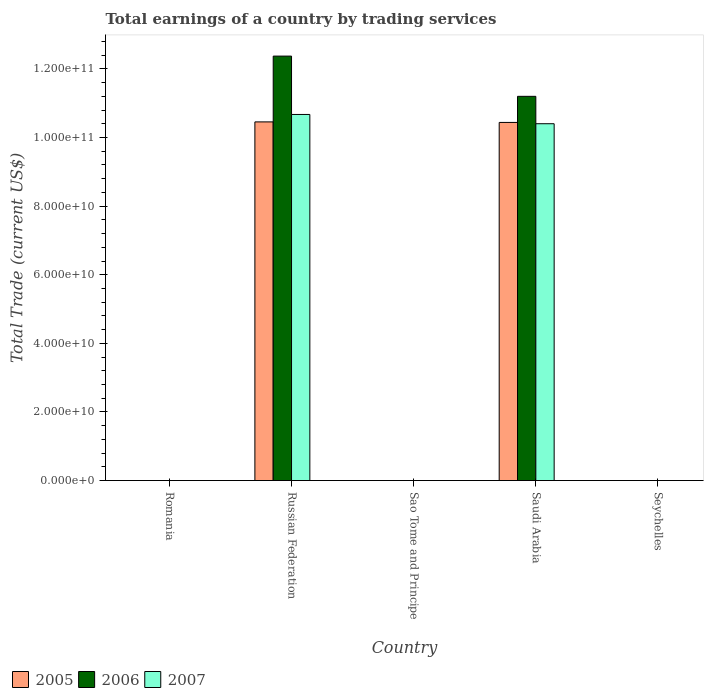How many different coloured bars are there?
Your response must be concise. 3. Are the number of bars on each tick of the X-axis equal?
Your answer should be compact. No. How many bars are there on the 3rd tick from the right?
Your response must be concise. 0. What is the label of the 4th group of bars from the left?
Provide a succinct answer. Saudi Arabia. What is the total earnings in 2005 in Russian Federation?
Your answer should be compact. 1.05e+11. Across all countries, what is the maximum total earnings in 2005?
Keep it short and to the point. 1.05e+11. Across all countries, what is the minimum total earnings in 2005?
Give a very brief answer. 0. In which country was the total earnings in 2007 maximum?
Your answer should be compact. Russian Federation. What is the total total earnings in 2006 in the graph?
Keep it short and to the point. 2.36e+11. What is the difference between the total earnings in 2007 in Russian Federation and that in Saudi Arabia?
Provide a succinct answer. 2.70e+09. What is the average total earnings in 2006 per country?
Give a very brief answer. 4.72e+1. What is the difference between the total earnings of/in 2006 and total earnings of/in 2007 in Russian Federation?
Offer a terse response. 1.70e+1. In how many countries, is the total earnings in 2006 greater than 12000000000 US$?
Provide a succinct answer. 2. What is the ratio of the total earnings in 2005 in Russian Federation to that in Saudi Arabia?
Offer a terse response. 1. What is the difference between the highest and the lowest total earnings in 2006?
Ensure brevity in your answer.  1.24e+11. In how many countries, is the total earnings in 2007 greater than the average total earnings in 2007 taken over all countries?
Make the answer very short. 2. How many countries are there in the graph?
Your answer should be compact. 5. What is the difference between two consecutive major ticks on the Y-axis?
Offer a very short reply. 2.00e+1. Does the graph contain any zero values?
Provide a short and direct response. Yes. How many legend labels are there?
Keep it short and to the point. 3. How are the legend labels stacked?
Your answer should be very brief. Horizontal. What is the title of the graph?
Your answer should be compact. Total earnings of a country by trading services. Does "1976" appear as one of the legend labels in the graph?
Keep it short and to the point. No. What is the label or title of the Y-axis?
Provide a short and direct response. Total Trade (current US$). What is the Total Trade (current US$) of 2006 in Romania?
Your response must be concise. 0. What is the Total Trade (current US$) in 2005 in Russian Federation?
Give a very brief answer. 1.05e+11. What is the Total Trade (current US$) in 2006 in Russian Federation?
Make the answer very short. 1.24e+11. What is the Total Trade (current US$) of 2007 in Russian Federation?
Keep it short and to the point. 1.07e+11. What is the Total Trade (current US$) of 2005 in Sao Tome and Principe?
Make the answer very short. 0. What is the Total Trade (current US$) in 2005 in Saudi Arabia?
Ensure brevity in your answer.  1.04e+11. What is the Total Trade (current US$) of 2006 in Saudi Arabia?
Your response must be concise. 1.12e+11. What is the Total Trade (current US$) in 2007 in Saudi Arabia?
Ensure brevity in your answer.  1.04e+11. Across all countries, what is the maximum Total Trade (current US$) of 2005?
Make the answer very short. 1.05e+11. Across all countries, what is the maximum Total Trade (current US$) in 2006?
Ensure brevity in your answer.  1.24e+11. Across all countries, what is the maximum Total Trade (current US$) of 2007?
Ensure brevity in your answer.  1.07e+11. Across all countries, what is the minimum Total Trade (current US$) in 2006?
Give a very brief answer. 0. Across all countries, what is the minimum Total Trade (current US$) of 2007?
Provide a succinct answer. 0. What is the total Total Trade (current US$) in 2005 in the graph?
Keep it short and to the point. 2.09e+11. What is the total Total Trade (current US$) in 2006 in the graph?
Your response must be concise. 2.36e+11. What is the total Total Trade (current US$) of 2007 in the graph?
Your answer should be compact. 2.11e+11. What is the difference between the Total Trade (current US$) in 2005 in Russian Federation and that in Saudi Arabia?
Offer a terse response. 1.54e+08. What is the difference between the Total Trade (current US$) in 2006 in Russian Federation and that in Saudi Arabia?
Your response must be concise. 1.17e+1. What is the difference between the Total Trade (current US$) of 2007 in Russian Federation and that in Saudi Arabia?
Give a very brief answer. 2.70e+09. What is the difference between the Total Trade (current US$) in 2005 in Russian Federation and the Total Trade (current US$) in 2006 in Saudi Arabia?
Make the answer very short. -7.45e+09. What is the difference between the Total Trade (current US$) of 2005 in Russian Federation and the Total Trade (current US$) of 2007 in Saudi Arabia?
Offer a very short reply. 5.34e+08. What is the difference between the Total Trade (current US$) in 2006 in Russian Federation and the Total Trade (current US$) in 2007 in Saudi Arabia?
Your answer should be very brief. 1.97e+1. What is the average Total Trade (current US$) in 2005 per country?
Your answer should be compact. 4.18e+1. What is the average Total Trade (current US$) of 2006 per country?
Your response must be concise. 4.72e+1. What is the average Total Trade (current US$) of 2007 per country?
Your response must be concise. 4.22e+1. What is the difference between the Total Trade (current US$) in 2005 and Total Trade (current US$) in 2006 in Russian Federation?
Ensure brevity in your answer.  -1.92e+1. What is the difference between the Total Trade (current US$) in 2005 and Total Trade (current US$) in 2007 in Russian Federation?
Provide a short and direct response. -2.17e+09. What is the difference between the Total Trade (current US$) of 2006 and Total Trade (current US$) of 2007 in Russian Federation?
Your answer should be compact. 1.70e+1. What is the difference between the Total Trade (current US$) in 2005 and Total Trade (current US$) in 2006 in Saudi Arabia?
Offer a terse response. -7.61e+09. What is the difference between the Total Trade (current US$) in 2005 and Total Trade (current US$) in 2007 in Saudi Arabia?
Your response must be concise. 3.80e+08. What is the difference between the Total Trade (current US$) of 2006 and Total Trade (current US$) of 2007 in Saudi Arabia?
Provide a succinct answer. 7.99e+09. What is the ratio of the Total Trade (current US$) in 2005 in Russian Federation to that in Saudi Arabia?
Your response must be concise. 1. What is the ratio of the Total Trade (current US$) of 2006 in Russian Federation to that in Saudi Arabia?
Give a very brief answer. 1.1. What is the difference between the highest and the lowest Total Trade (current US$) in 2005?
Provide a short and direct response. 1.05e+11. What is the difference between the highest and the lowest Total Trade (current US$) of 2006?
Offer a terse response. 1.24e+11. What is the difference between the highest and the lowest Total Trade (current US$) in 2007?
Your response must be concise. 1.07e+11. 